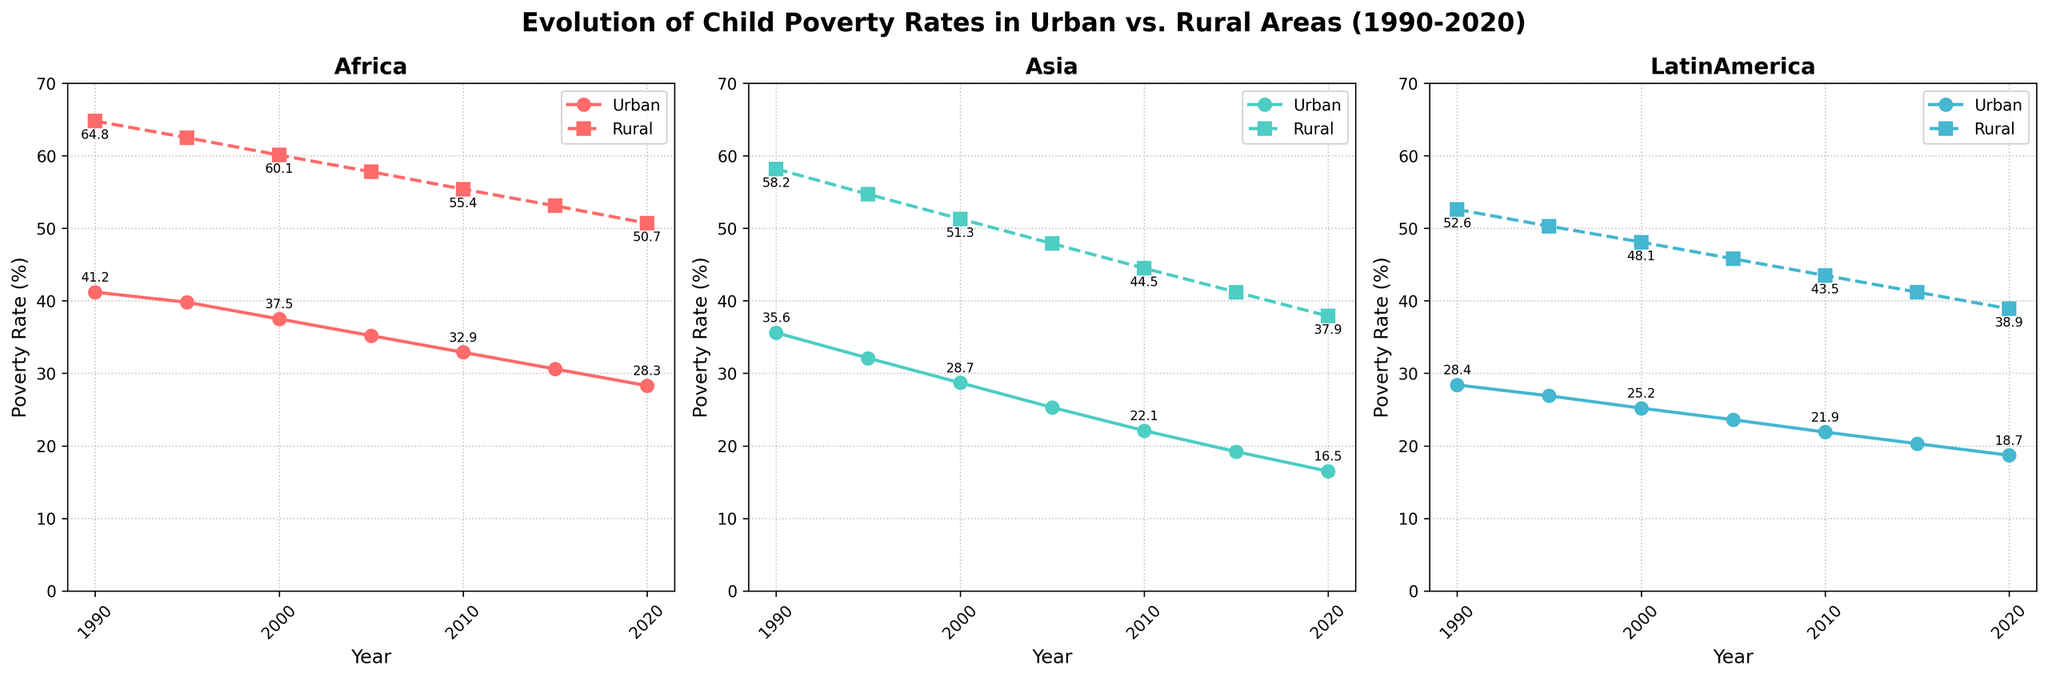What is the overall trend in child poverty rates in urban Africa from 1990 to 2020? The child poverty rate in urban Africa shows a decreasing trend. Starting from 41.2% in 1990, it drops steadily to 28.3% in 2020. A continuous downward trajectory can be observed.
Answer: Decreasing Which area had a higher child poverty rate in 2000, rural Asia or urban Latin America? In 2000, rural Asia had a poverty rate of 51.3%, while urban Latin America had a poverty rate of 25.2%. Comparing these values, we see that rural Asia had a higher rate.
Answer: Rural Asia By how many percentage points did the child poverty rate decrease in urban Asia from 1990 to 2020? In 1990, urban Asia had a child poverty rate of 35.6%, and by 2020, this rate had decreased to 16.5%. The difference is 35.6% - 16.5% = 19.1 percentage points.
Answer: 19.1 In which region is the gap between rural and urban child poverty rates the smallest in 2020? In 2020, the gaps are: 
- Africa: 50.7% - 28.3% = 22.4 percentage points 
- Asia: 37.9% - 16.5% = 21.4 percentage points
- Latin America: 38.9% - 18.7% = 20.2 percentage points 
Latin America has the smallest gap.
Answer: Latin America Between 1995 and 2010, which region experienced the largest decrease in child poverty rates in rural areas? Over this period, the decreases in rural poverty rates are as follows:
- Africa: 62.5% to 55.4% = 7.1 percentage points
- Asia: 54.7% to 44.5% = 10.2 percentage points
- Latin America: 50.3% to 43.5% = 6.8 percentage points
Asia experienced the largest decrease.
Answer: Asia In which year did urban Latin America first have a lower child poverty rate than 25%? The child poverty rate in urban Latin America first dropped below 25% in the year 2000, where it was recorded as 25.2%.
Answer: 2000 Which color represents the urban child poverty rate in Asia? The urban child poverty rate in Asia is represented by the color green (second subplot).
Answer: Green How did the child poverty rate in rural Africa in 2010 compare to that in urban Africa in 1995? In 2010, the child poverty rate in rural Africa was 55.4%. In urban Africa, it was 39.8% in 1995. Thus, the rate in rural Africa in 2010 was higher.
Answer: Higher By what percentage did the rural child poverty rate decrease in Latin America between 1990 and 2020? In 1990, the rural child poverty rate in Latin America was 52.6%. By 2020, it had decreased to 38.9%. The percentage decrease is calculated as:
((52.6 - 38.9) / 52.6) * 100 = 26.05%.
Answer: 26.05 Which region had the highest child poverty rate in rural areas in 1995, and what was it? In 1995, Africa had the highest rural child poverty rate at 62.5%.
Answer: Africa, 62.5% 